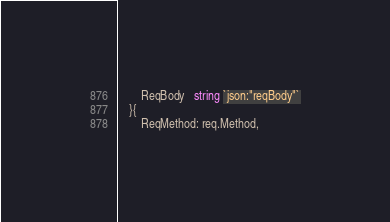<code> <loc_0><loc_0><loc_500><loc_500><_Go_>		ReqBody   string `json:"reqBody"`
	}{
		ReqMethod: req.Method,</code> 